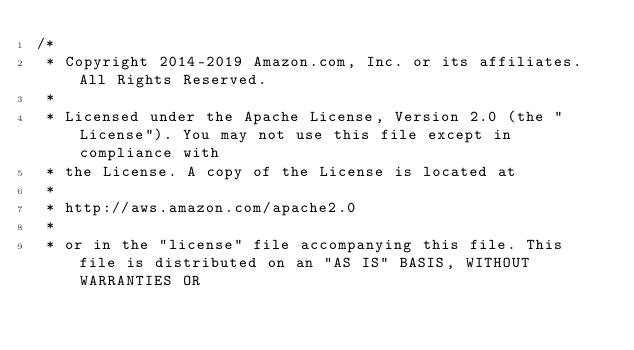Convert code to text. <code><loc_0><loc_0><loc_500><loc_500><_Java_>/*
 * Copyright 2014-2019 Amazon.com, Inc. or its affiliates. All Rights Reserved.
 * 
 * Licensed under the Apache License, Version 2.0 (the "License"). You may not use this file except in compliance with
 * the License. A copy of the License is located at
 * 
 * http://aws.amazon.com/apache2.0
 * 
 * or in the "license" file accompanying this file. This file is distributed on an "AS IS" BASIS, WITHOUT WARRANTIES OR</code> 